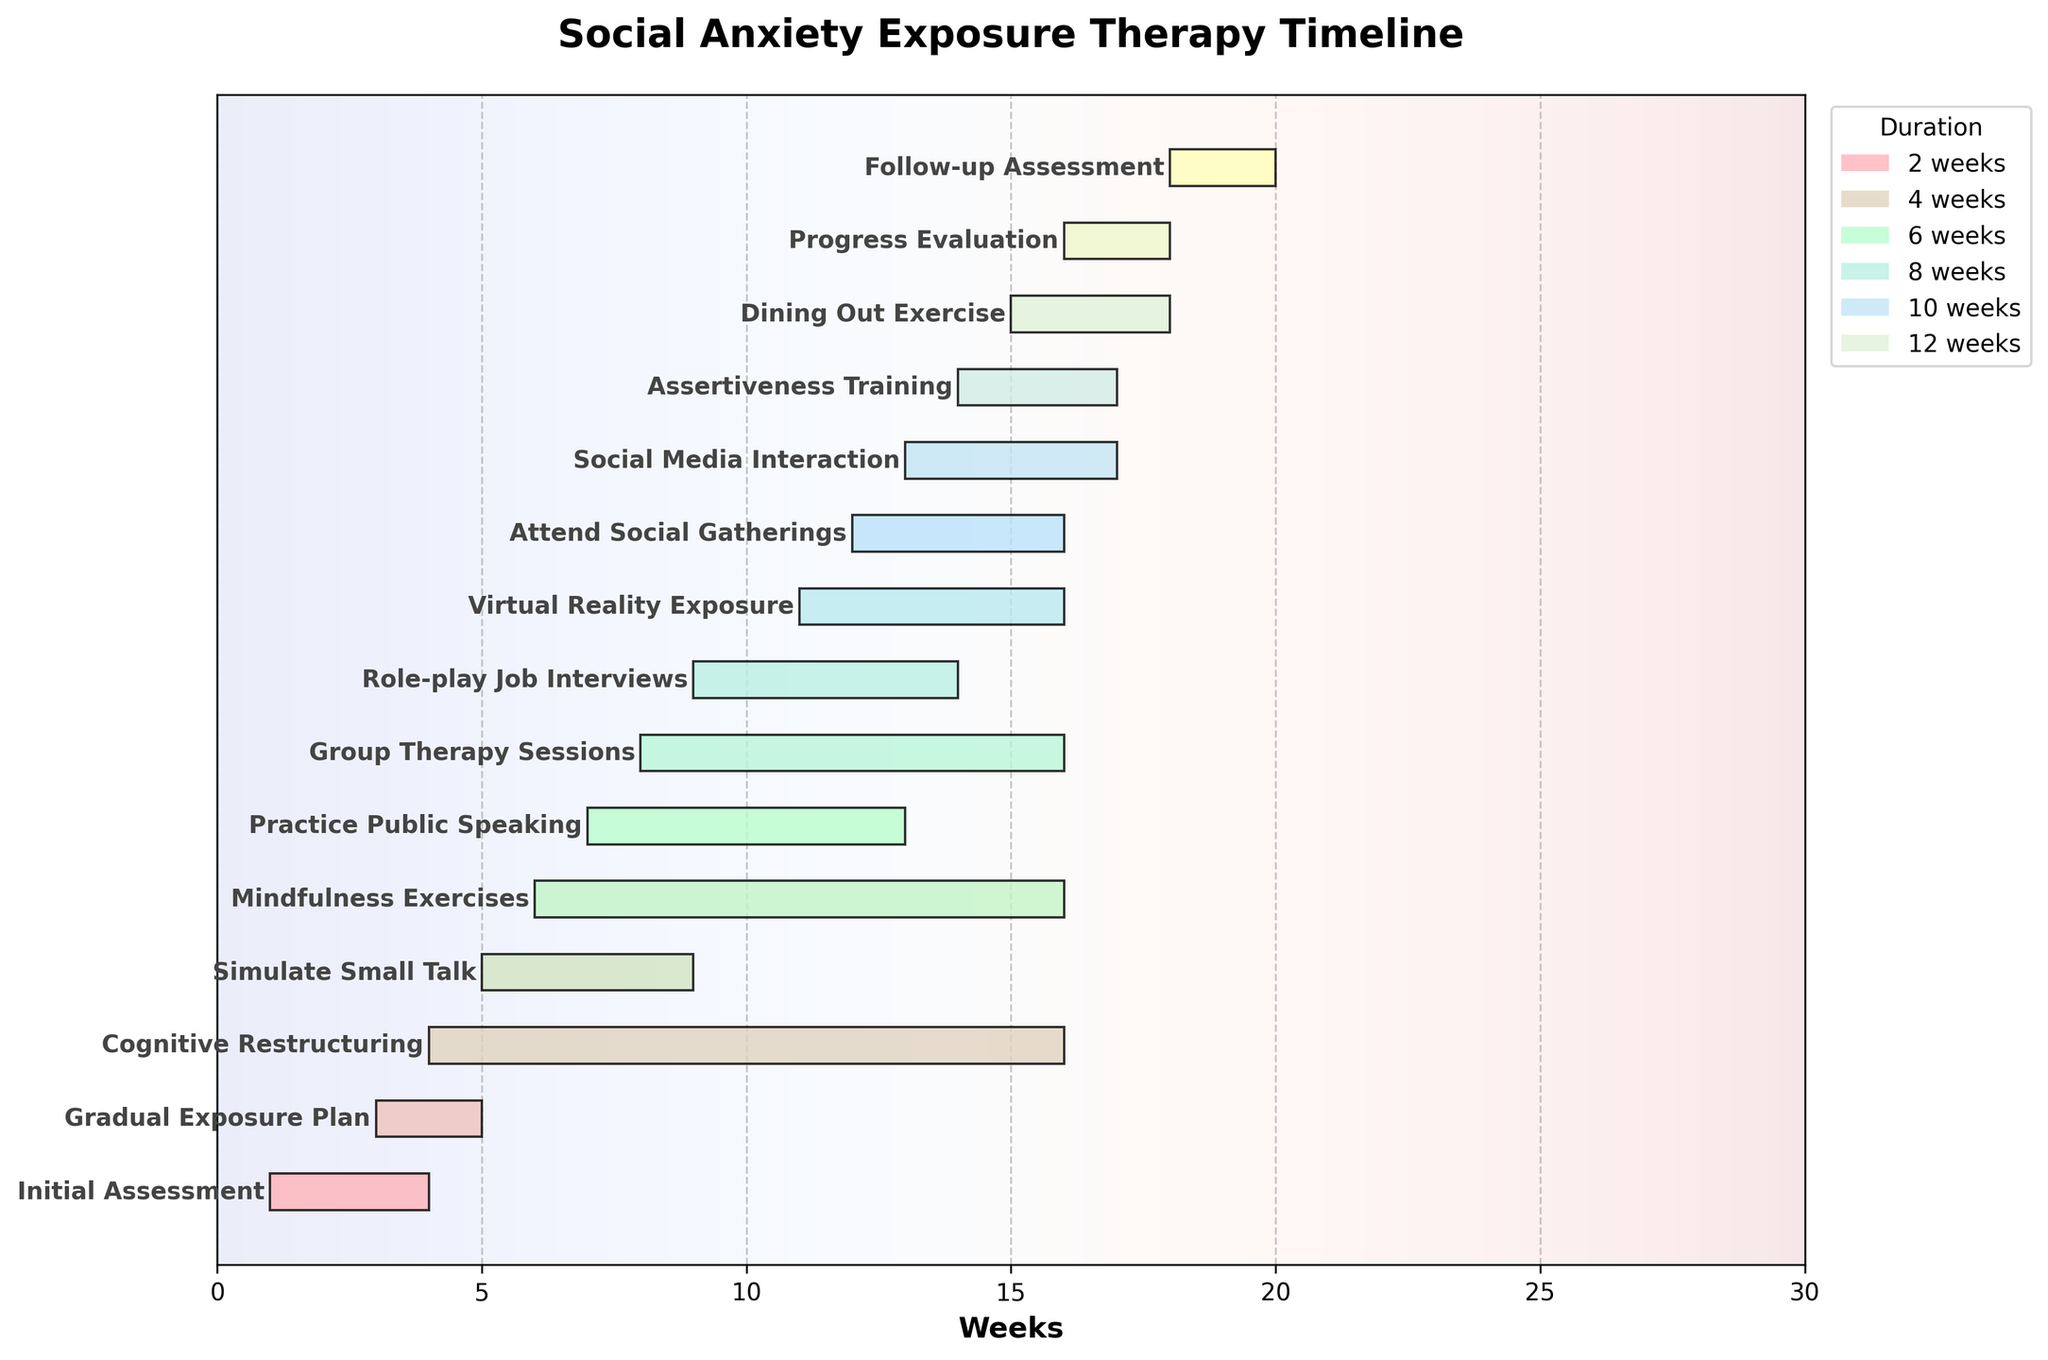What's the title of the chart? The title of the chart is displayed at the top and provides an overall description of what the chart represents. By reading the chart, the title can be observed directly.
Answer: Social Anxiety Exposure Therapy Timeline How many tasks are scheduled to start by week 5? From the figure, you can count the number of tasks that have a starting point from week 1 to week 5. These tasks are Initial Assessment (week 1), Gradual Exposure Plan (week 3), Cognitive Restructuring (week 4), and Simulate Small Talk (week 5).
Answer: Four tasks Which activity has the longest duration? The chart shows bars representing different tasks and their durations. By comparing the lengths of the bars, you can determine the activity with the longest bar. Cognitive Restructuring spans 12 weeks, the longest duration in the figure.
Answer: Cognitive Restructuring What is the combined duration of both assertiveness training and social media interaction? Locate the bars for Assertiveness Training and Social Media Interaction in the figure. Assertiveness Training has a duration of 3 weeks and Social Media Interaction is 4 weeks. Adding these gives 3 + 4.
Answer: 7 weeks Do any tasks overlap with the Practice Public Speaking task? The task Practice Public Speaking starts at week 7 and ends at week 13. By analyzing the chart, you can see if any other tasks are scheduled during this period. Role-play Job Interviews, Group Therapy Sessions, Virtual Reality Exposure, Cognitive Restructuring, and Mindfulness Exercises overlap with this task.
Answer: Yes Between Role-play Job Interviews and Virtual Reality Exposure, which task starts later? By looking at the starting points of the tasks represented in the chart, Role-play Job Interviews starts in week 9 and Virtual Reality Exposure starts in week 11. Therefore, Virtual Reality Exposure starts later.
Answer: Virtual Reality Exposure How many tasks have a duration of 5 weeks? By examining the chart, you can count the number of tasks that have bars spanning exactly 5 weeks. Role-play Job Interviews and Virtual Reality Exposure each have a duration of 5 weeks.
Answer: Two tasks Which task ends first after attending social gatherings? To determine this, find where the Attend Social Gatherings task ends (week 16). Then look for tasks ending just after this period and find the first one. The Progress Evaluation task ends at week 18.
Answer: Progress Evaluation Are there any tasks that end at the same time Follow-up Assessment starts? Follow-up Assessment starts at week 18. By checking the ending points of other tasks, the Dining Out Exercise ends just before the Follow-up Assessment starts.
Answer: No 